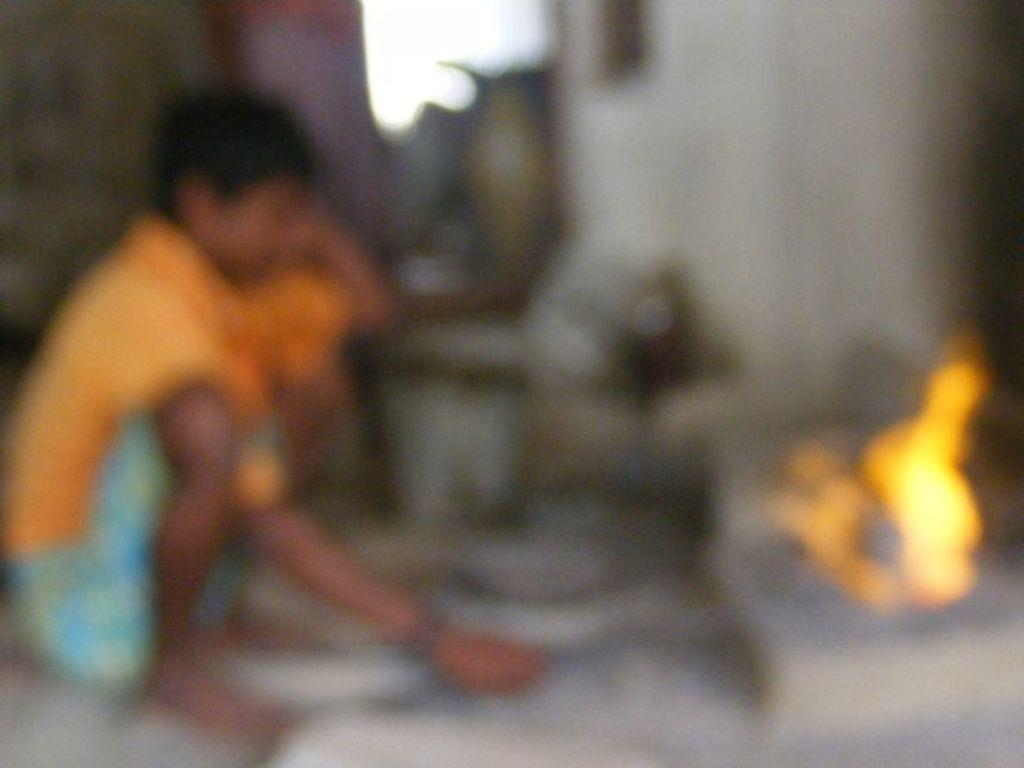What is located on the left side of the image? There is a boy on the left side of the image. What is the boy doing in the image? The boy is in a squat position and holding sticks. What can be seen on the right side of the image? There is a fire on the right side of the image. What architectural feature is visible at the top of the image? There is a window visible at the top of the image. What else is present in the image besides the boy and the fire? There are objects present in the image. Can you see the ocean in the image? No, there is no ocean visible in the image. What type of nut is the boy holding? The boy is holding sticks, not a nut. 